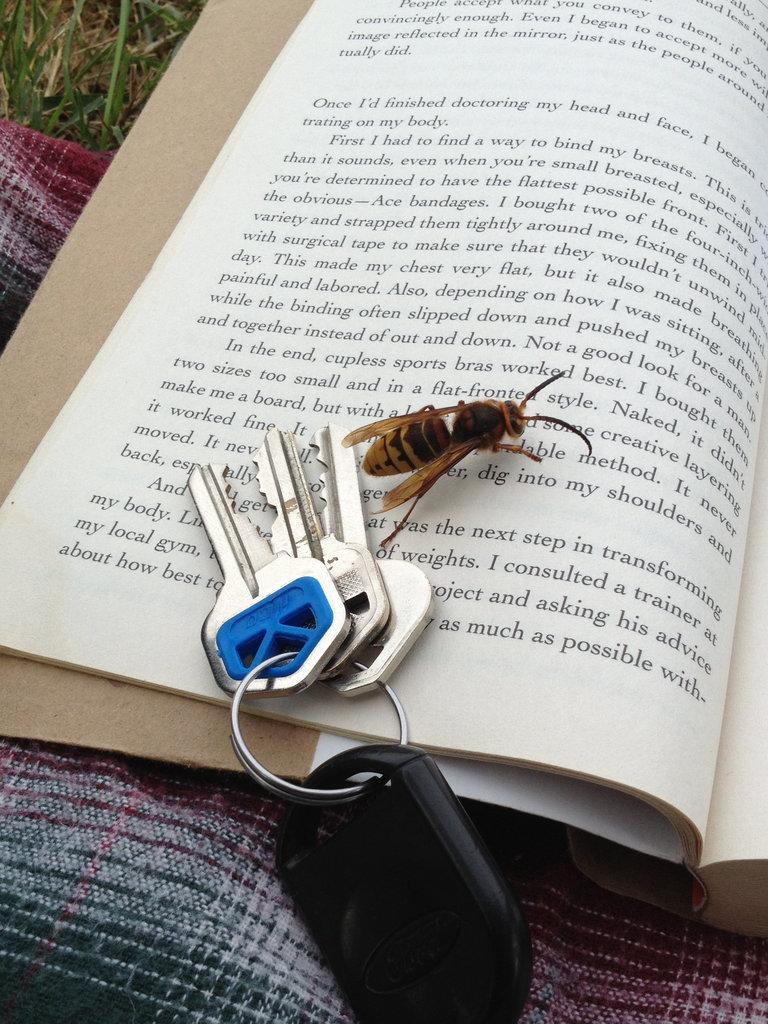What object related to reading can be seen in the image? There is a book in the image. What small creature is present in the image? There is an insect in the image. What type of object is used for unlocking in the image? There are keys in the image. What type of slope can be seen in the image? There is no slope present in the image. What type of coil is visible in the image? There is no coil present in the image. 